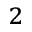Convert formula to latex. <formula><loc_0><loc_0><loc_500><loc_500>^ { 2 }</formula> 